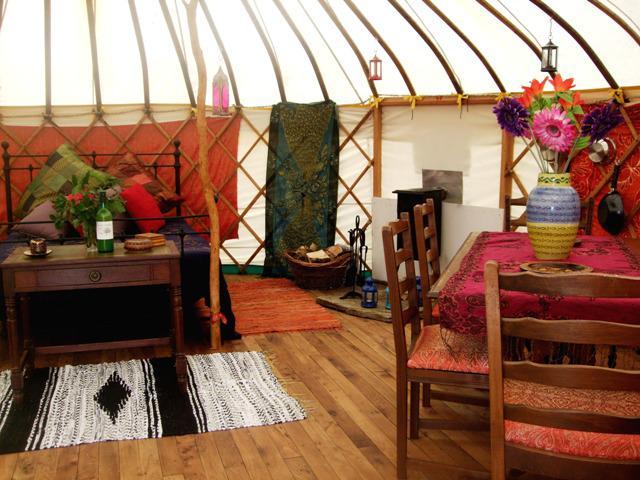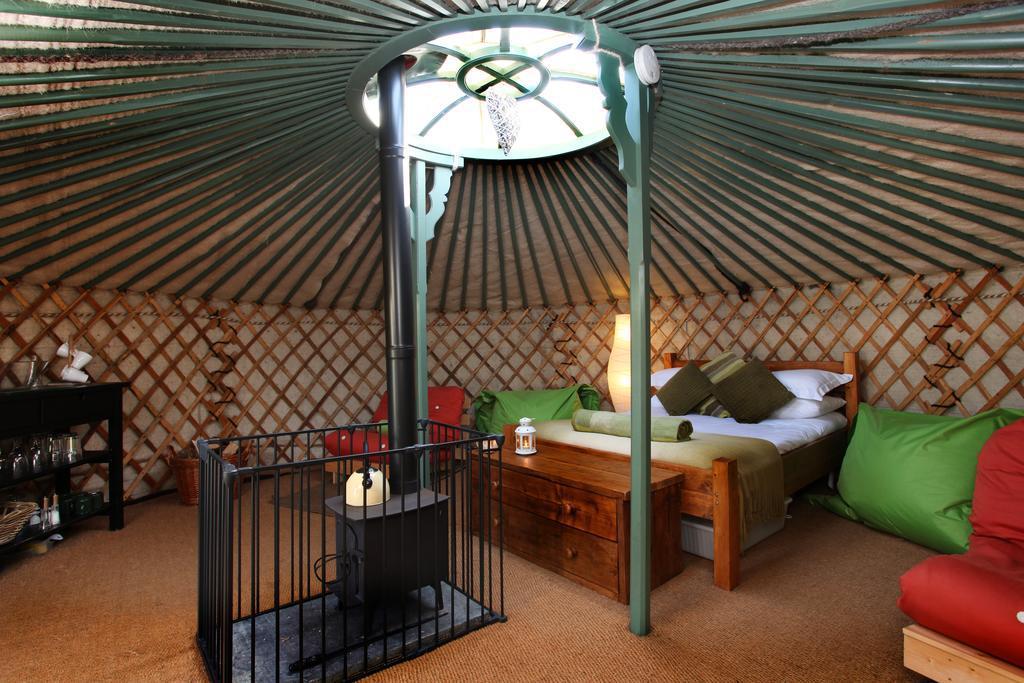The first image is the image on the left, the second image is the image on the right. For the images shown, is this caption "Left and right images feature a bedroom inside a yurt, and at least one bedroom features a bed flanked by wooden nightstands." true? Answer yes or no. No. 